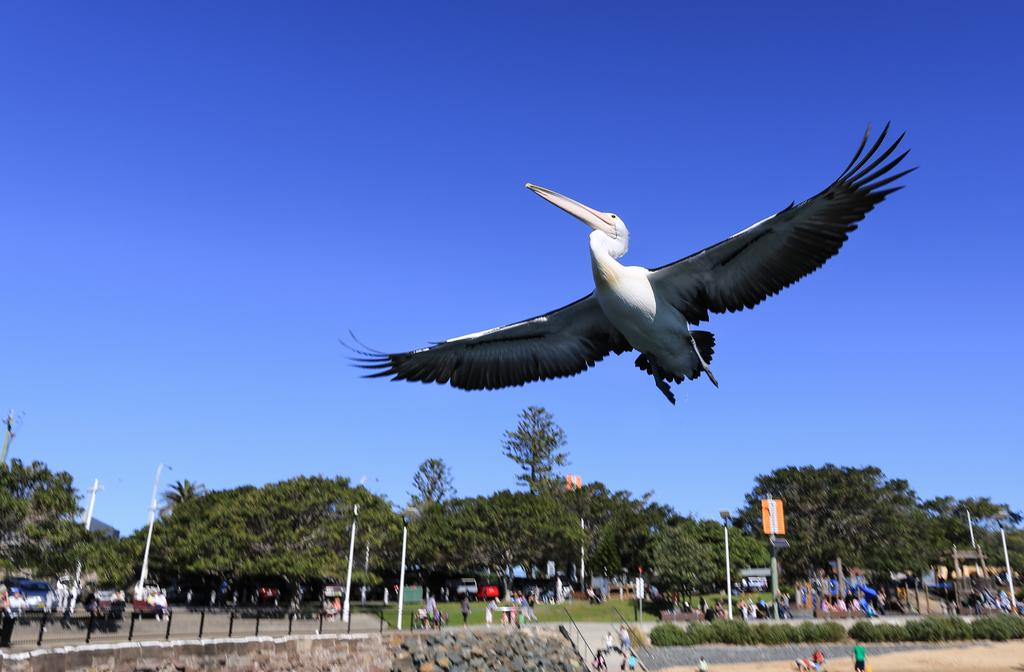What is the main subject of the image? The main subject of the image is a bird flying in the air. What can be seen in the background of the image? In the background of the image, there are persons, poles, plants, trees, vehicles, a board on a pole, other objects, and the sky. Can you describe the objects in the background? The objects in the background include poles, a board on a pole, and other unspecified objects. There are also trees, plants, and vehicles visible. What is the condition of the sky in the image? The sky is visible in the background of the image. What type of education is being taught in the image? There is no indication of any educational activity in the image. How much growth has the bird experienced since the last time it was in the image? The image does not provide any information about the bird's growth or previous appearances. 